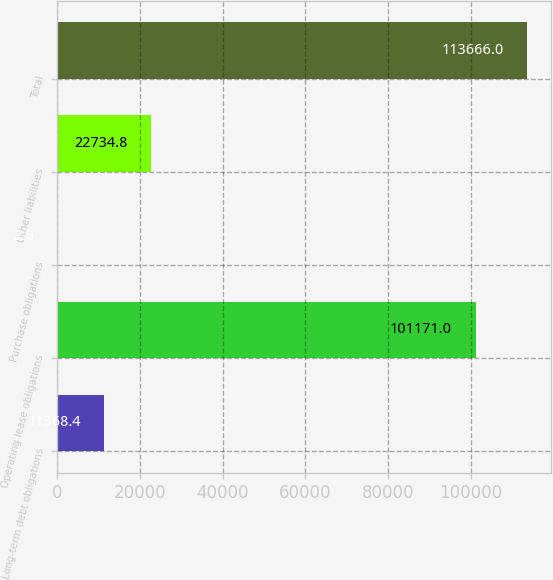Convert chart to OTSL. <chart><loc_0><loc_0><loc_500><loc_500><bar_chart><fcel>Long-term debt obligations<fcel>Operating lease obligations<fcel>Purchase obligations<fcel>Other liabilities<fcel>Total<nl><fcel>11368.4<fcel>101171<fcel>2<fcel>22734.8<fcel>113666<nl></chart> 